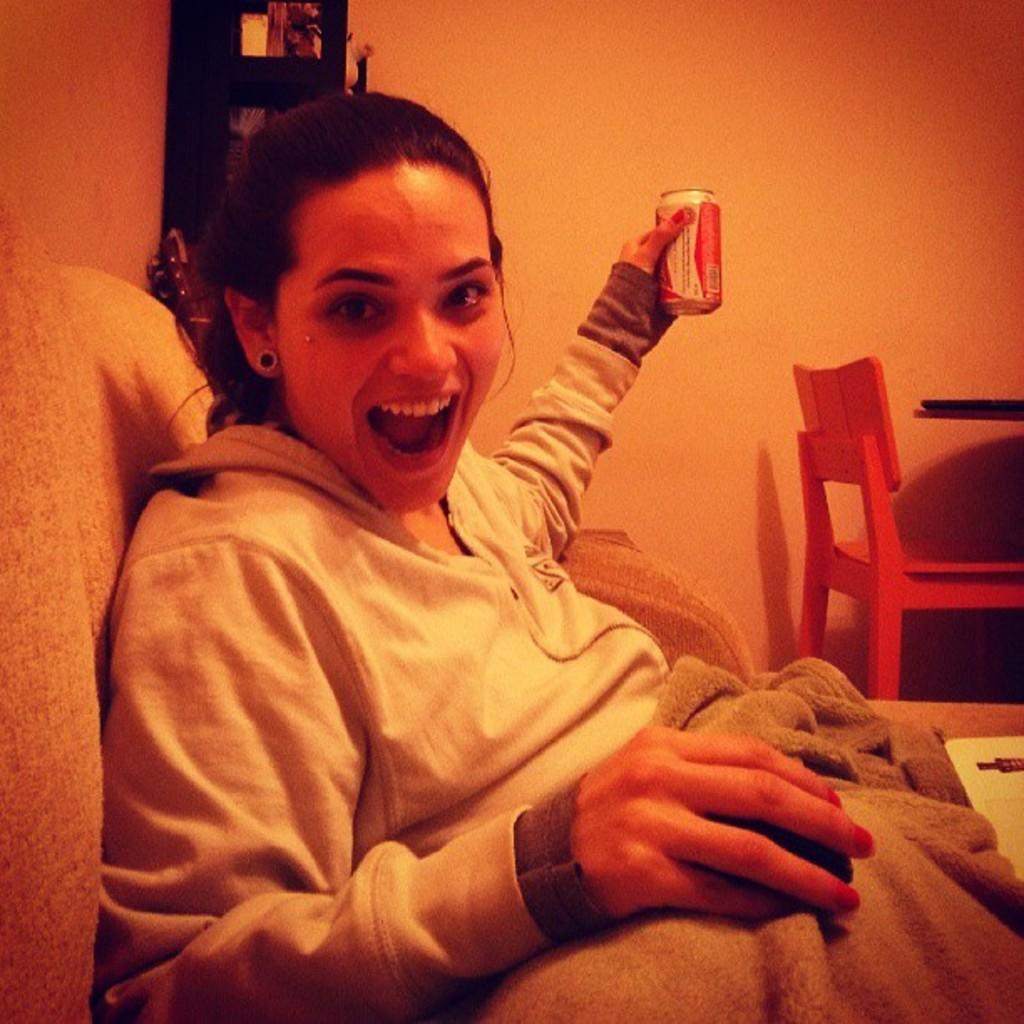Who is present in the image? There is a woman in the image. What is the woman doing in the image? The woman is seated and smiling. What is the woman holding in her hand? The woman is holding a tin in her hand. What type of hook is the woman using to hang the paste on the cracker in the image? There is no hook, paste, or cracker present in the image. 